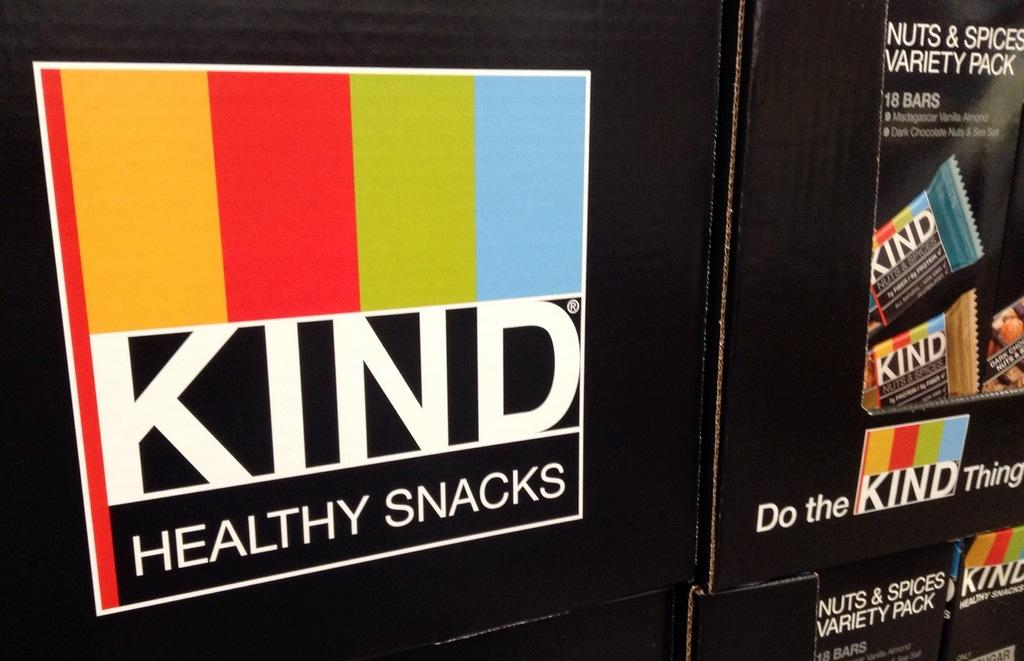What type of items can be seen in the image? There are snacks boxes in the image. Can you describe the snacks boxes in more detail? Unfortunately, the image does not provide enough detail to describe the snacks boxes further. Are there any other objects or people visible in the image? The provided facts do not mention any other objects or people in the image. How long does it take for the wall to exist in the image? There is no wall present in the image, so it is not possible to determine how long it takes for the wall to exist. 